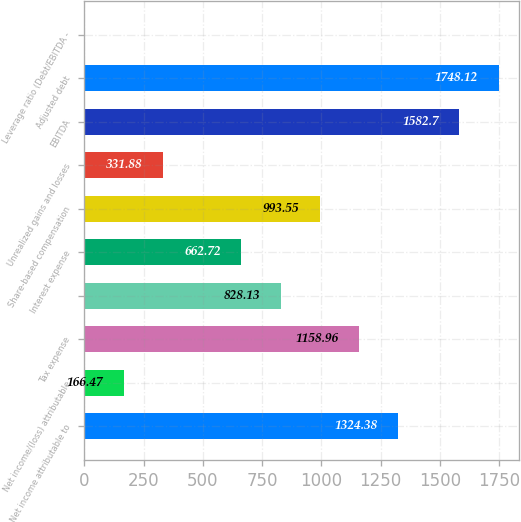<chart> <loc_0><loc_0><loc_500><loc_500><bar_chart><fcel>Net income attributable to<fcel>Net income/(loss) attributable<fcel>Tax expense<fcel>Unnamed: 3<fcel>Interest expense<fcel>Share-based compensation<fcel>Unrealized gains and losses<fcel>EBITDA<fcel>Adjusted debt<fcel>Leverage ratio (Debt/EBITDA -<nl><fcel>1324.38<fcel>166.47<fcel>1158.96<fcel>828.13<fcel>662.72<fcel>993.55<fcel>331.88<fcel>1582.7<fcel>1748.12<fcel>1.05<nl></chart> 